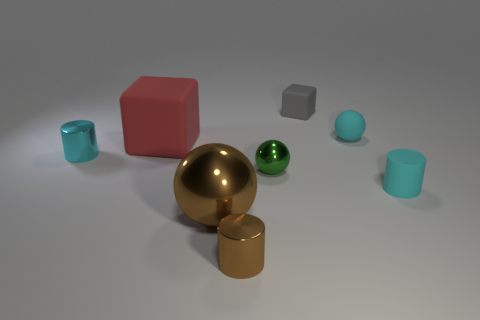There is a brown object that is behind the brown metal cylinder; is there a red thing on the right side of it?
Give a very brief answer. No. What material is the small green sphere?
Provide a succinct answer. Metal. Are there any small matte objects on the left side of the cyan sphere?
Provide a short and direct response. Yes. What size is the brown metal thing that is the same shape as the small green shiny object?
Your answer should be very brief. Large. Are there an equal number of cyan shiny objects in front of the brown cylinder and big rubber blocks behind the red block?
Offer a terse response. Yes. What number of metallic spheres are there?
Your response must be concise. 2. Are there more matte objects right of the gray cube than tiny cyan balls?
Your response must be concise. Yes. What material is the cyan thing left of the small green metal object?
Your answer should be compact. Metal. There is another matte object that is the same shape as the gray object; what color is it?
Provide a succinct answer. Red. How many tiny shiny things have the same color as the big metal thing?
Give a very brief answer. 1. 